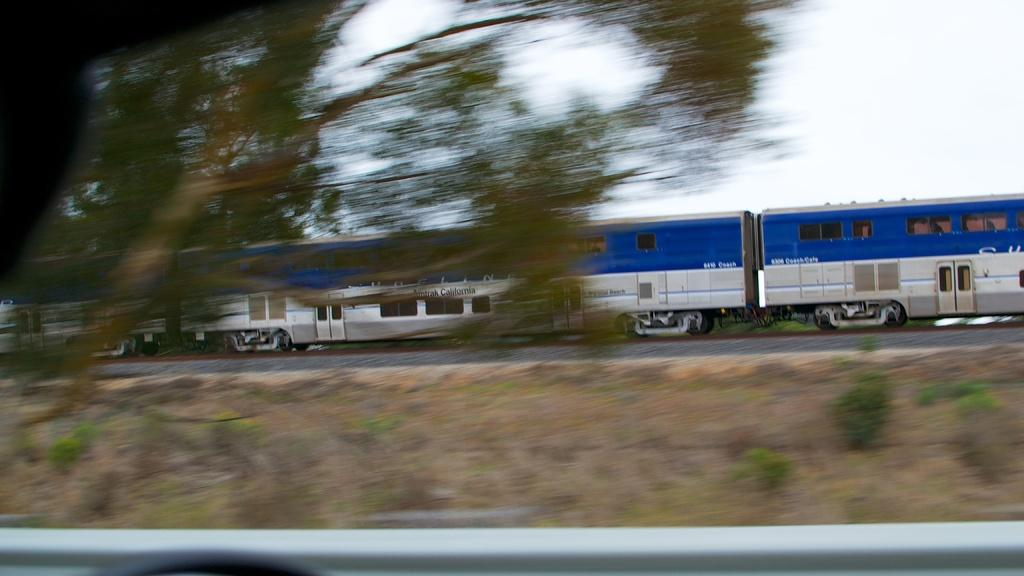What is the main subject of the image? The main subject of the image is a train. Where is the train located in the image? The train is on a railway track. What can be seen on the left side of the image? There is a tree on the left side of the image. What is visible in the background of the image? The sky is visible in the background of the image. What type of jeans is the train wearing in the image? Trains do not wear jeans; they are inanimate objects. 